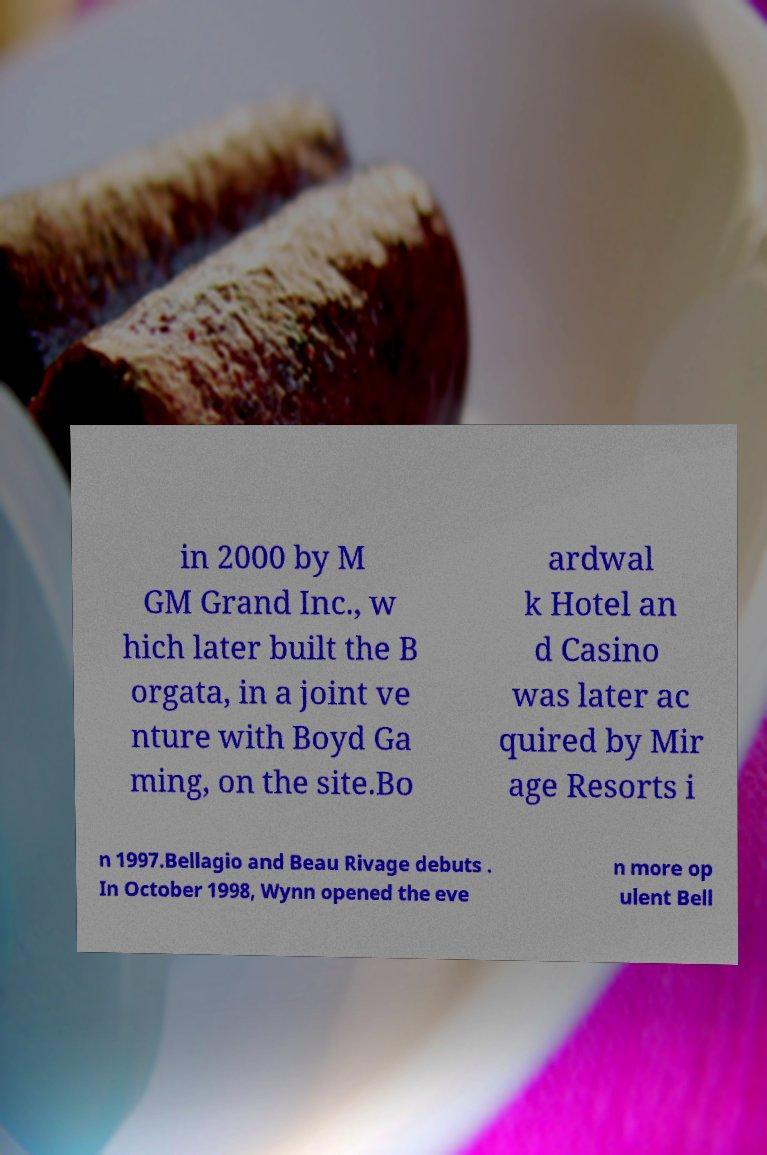Could you assist in decoding the text presented in this image and type it out clearly? in 2000 by M GM Grand Inc., w hich later built the B orgata, in a joint ve nture with Boyd Ga ming, on the site.Bo ardwal k Hotel an d Casino was later ac quired by Mir age Resorts i n 1997.Bellagio and Beau Rivage debuts . In October 1998, Wynn opened the eve n more op ulent Bell 